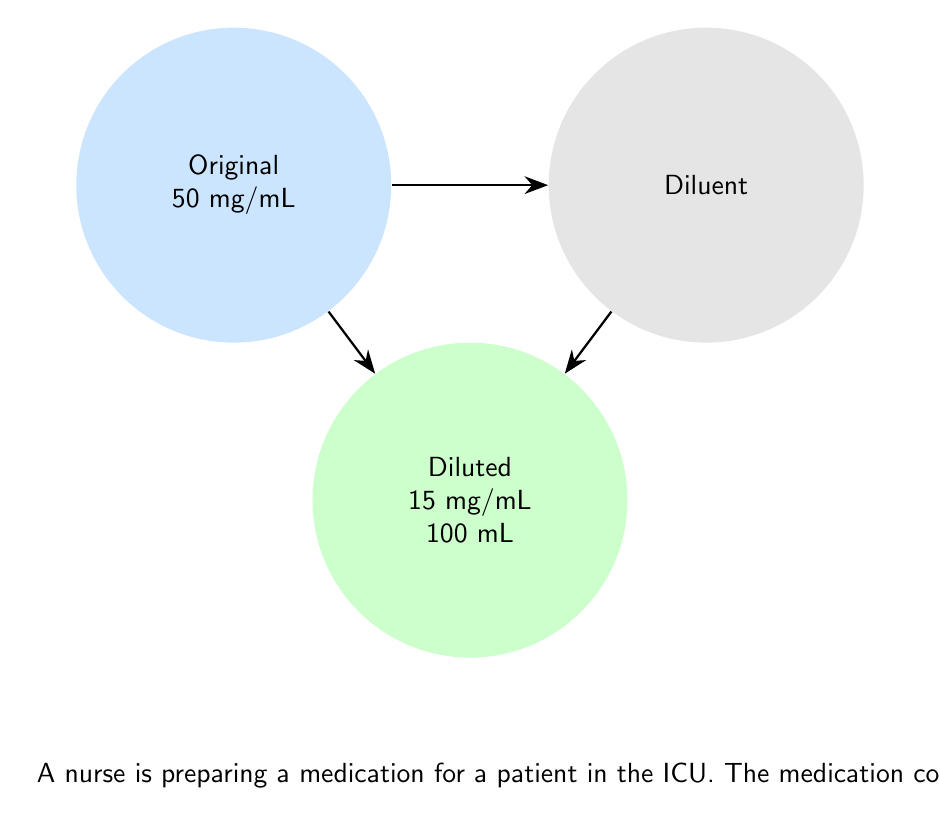Can you answer this question? Let's approach this step-by-step using ratios and proportions:

1) First, we need to determine the ratio of the original concentration to the desired concentration:
   $\frac{\text{Original concentration}}{\text{Desired concentration}} = \frac{50 \text{ mg/mL}}{15 \text{ mg/mL}} = \frac{10}{3}$

2) This ratio tells us that for every 3 parts of the final solution, 1 part should be the original medication.

3) We need to prepare 100 mL of the diluted solution. Let's call the volume of original medication $x$ mL.
   Then, the proportion can be set up as:
   $\frac{x}{100} = \frac{1}{3}$

4) Cross multiply:
   $3x = 100$

5) Solve for $x$:
   $x = \frac{100}{3} = 33.33$ mL

6) Round to the nearest 0.1 mL:
   $x \approx 33.3$ mL

7) To find the amount of diluent, subtract the volume of original medication from the total volume:
   Diluent = 100 mL - 33.3 mL = 66.7 mL

Therefore, the nurse should use 33.3 mL of the original medication and add 66.7 mL of diluent.
Answer: 33.3 mL original medication, 66.7 mL diluent 